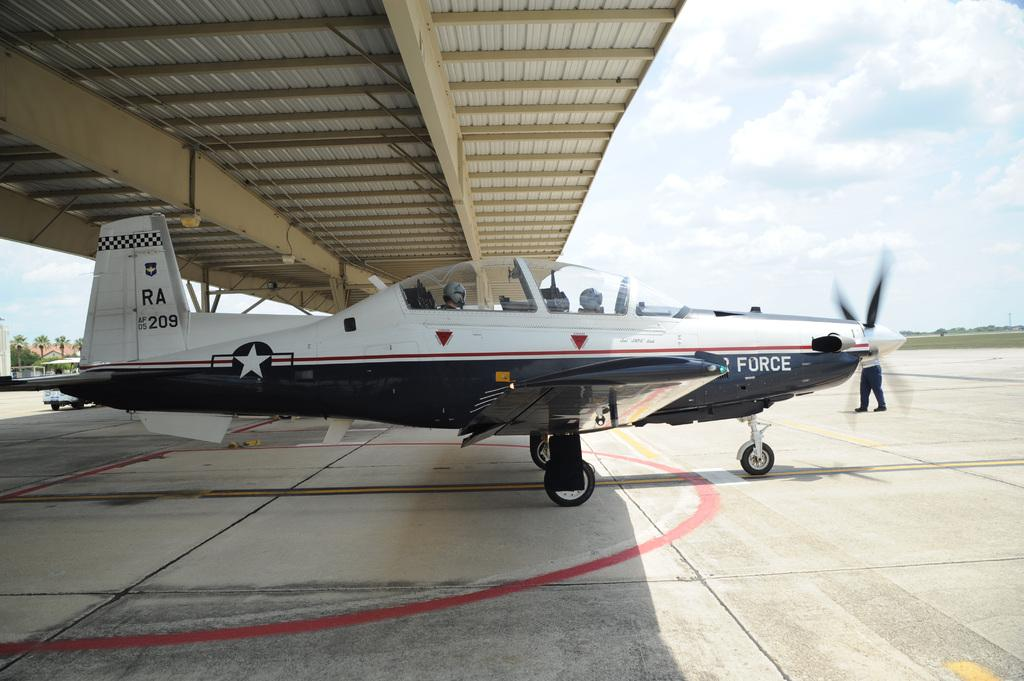<image>
Offer a succinct explanation of the picture presented. An Air Force plane bears the number 209 on its rear section. 